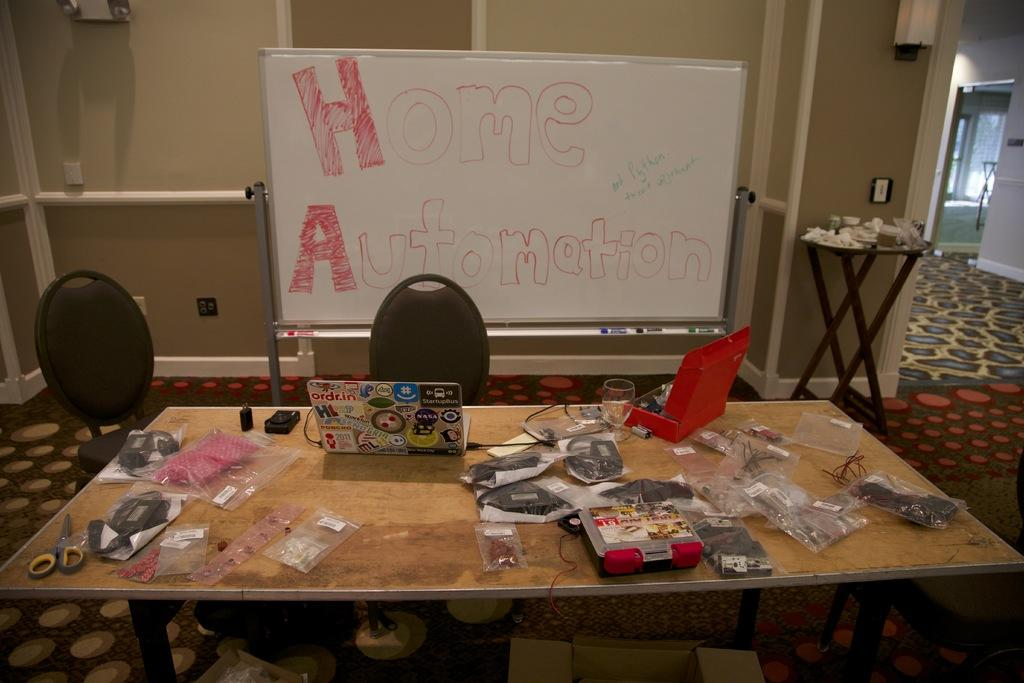What is the main piece of furniture in the image? There is a table in the image. What electronic device is on the table? There is a laptop on the table. What type of tool is on the table? There are scissors on the table. What material is used to cover the items on the table? There are covers on the table. What is used for writing or drawing on the table? There is paper on the table. What is used for drinking in the image? There is a glass on the table. What type of seating is in the image? There is a chair in the image. What is the flat, elevated surface in the image? There is a board in the image. What is used to support or hold something in the image? There is a stand in the image. What type of floor covering is in the image? There is a carpet in the image. What provides illumination in the image? There is a light in the image. Can you tell me how many tickets are on the table in the image? There are no tickets present in the image. What type of sugar is used to sweeten the drink in the glass? There is no sugar mentioned or visible in the image. 